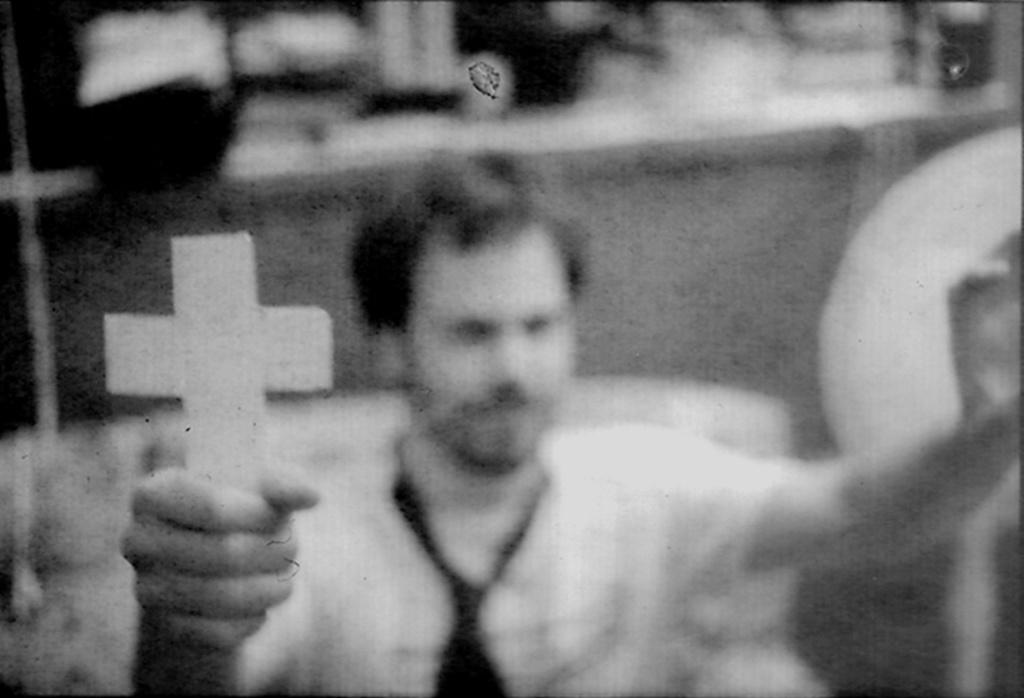Who is the main subject in the image? There is a man in the center of the image. What is the man holding in the image? The man is holding a plus sign. Can you describe the background of the image? The background of the image is blurred. What type of coal can be seen in the image? There is no coal present in the image. Is there a train visible in the background of the image? There is no train present in the image. 